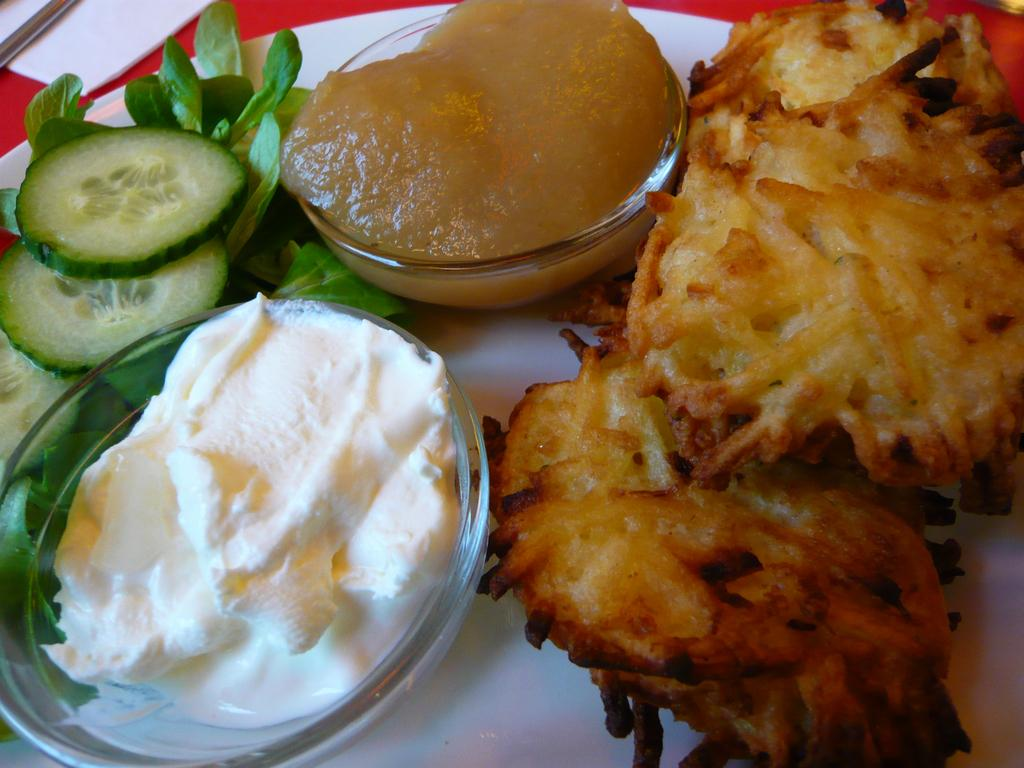What is on the plate in the image? There is food present in the image. How many cups can be seen in the image? There are two cups in the image. Where is the tissue paper located in the image? The tissue paper is at the left top of the image. What theory is being proposed in the image? There is no theory present in the image; it features a plate, two cups, food, and a tissue paper. How does the voyage of the cups affect the balance of the image? There is no voyage or balance being depicted in the image; it is a still scene with cups, a plate, food, and a tissue paper. 